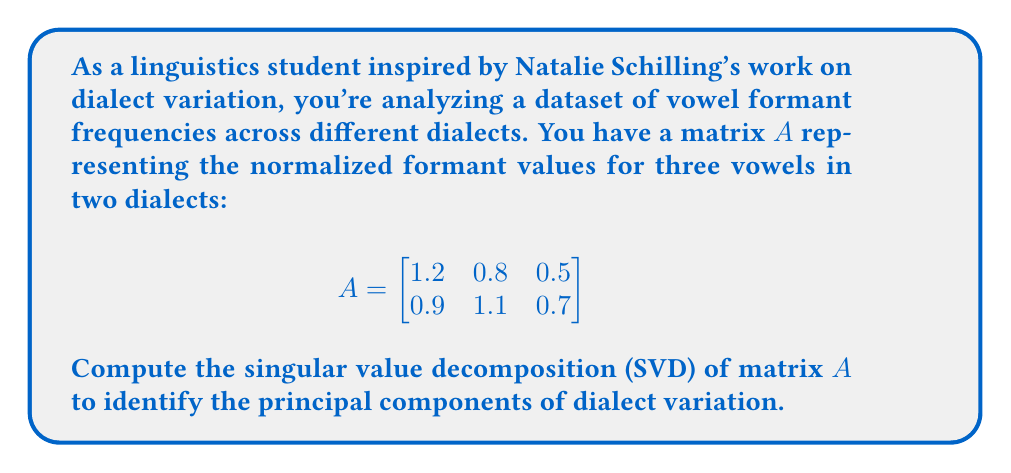Show me your answer to this math problem. To compute the singular value decomposition of matrix $A$, we need to find matrices $U$, $\Sigma$, and $V^T$ such that $A = U\Sigma V^T$.

Step 1: Compute $A^TA$ and $AA^T$
$$A^TA = \begin{bmatrix}
2.25 & 2.09 & 1.43 \\
2.09 & 1.97 & 1.35 \\
1.43 & 1.35 & 0.74
\end{bmatrix}$$

$$AA^T = \begin{bmatrix}
2.18 & 2.01 \\
2.01 & 1.91
\end{bmatrix}$$

Step 2: Find eigenvalues of $A^TA$ (which are the squares of singular values)
Solving $\det(A^TA - \lambda I) = 0$, we get:
$\lambda_1 \approx 4.9236$ and $\lambda_2 \approx 0.0364$

Step 3: Calculate singular values
$\sigma_1 = \sqrt{\lambda_1} \approx 2.2189$
$\sigma_2 = \sqrt{\lambda_2} \approx 0.1908$

Step 4: Compute right singular vectors (eigenvectors of $A^TA$)
For $\lambda_1$: $v_1 \approx [0.6506, 0.6190, 0.4400]^T$
For $\lambda_2$: $v_2 \approx [-0.5257, 0.7854, -0.3267]^T$

Step 5: Compute left singular vectors
$u_1 = \frac{1}{\sigma_1}Av_1 \approx [0.7071, 0.7071]^T$
$u_2 = \frac{1}{\sigma_2}Av_2 \approx [-0.7071, 0.7071]^T$

Step 6: Construct matrices $U$, $\Sigma$, and $V^T$
$$U = \begin{bmatrix}
0.7071 & -0.7071 \\
0.7071 & 0.7071
\end{bmatrix}$$

$$\Sigma = \begin{bmatrix}
2.2189 & 0 \\
0 & 0.1908 \\
0 & 0
\end{bmatrix}$$

$$V^T = \begin{bmatrix}
0.6506 & 0.6190 & 0.4400 \\
-0.5257 & 0.7854 & -0.3267
\end{bmatrix}$$
Answer: $A = U\Sigma V^T$, where:
$U = \begin{bmatrix} 0.7071 & -0.7071 \\ 0.7071 & 0.7071 \end{bmatrix}$
$\Sigma = \begin{bmatrix} 2.2189 & 0 \\ 0 & 0.1908 \\ 0 & 0 \end{bmatrix}$
$V^T = \begin{bmatrix} 0.6506 & 0.6190 & 0.4400 \\ -0.5257 & 0.7854 & -0.3267 \end{bmatrix}$ 